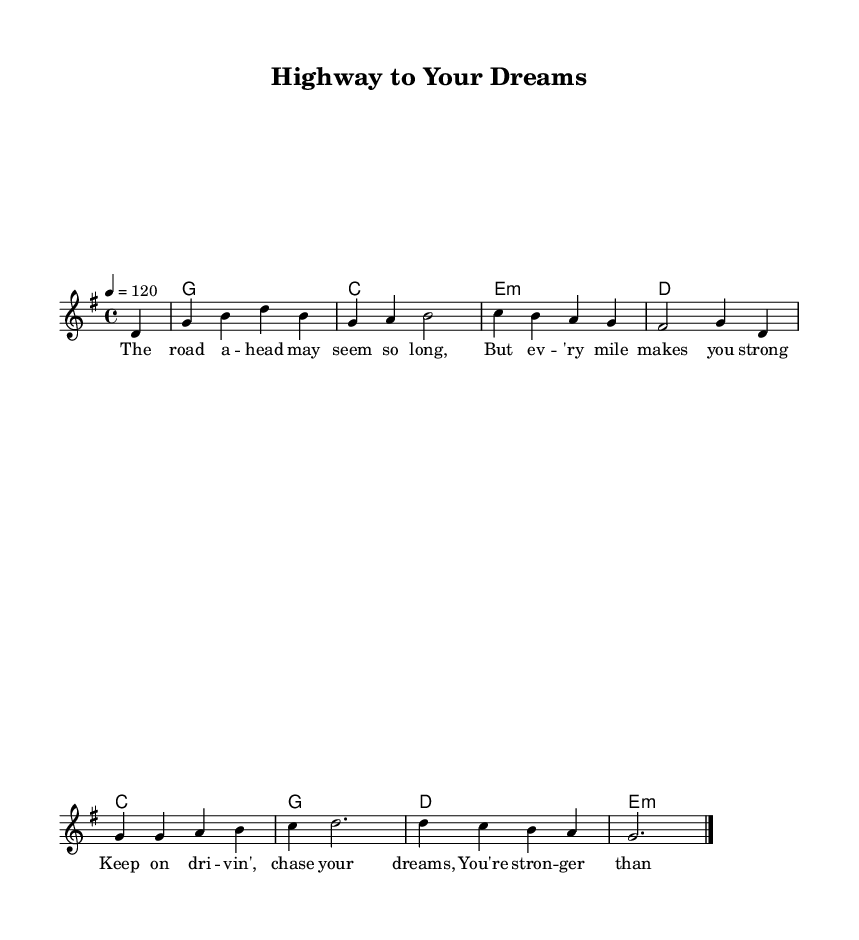What is the key signature of this music? The key signature is G major, which has one sharp (F#). This can be determined by looking at the beginning of the staff, where the key signature is indicated.
Answer: G major What is the time signature of this music? The time signature is 4/4, as shown at the beginning of the piece. It indicates there are four beats in each measure, and the quarter note gets one beat.
Answer: 4/4 What is the tempo marking for this piece? The tempo marking is 120 beats per minute, indicated by the tempo directive "4 = 120" at the start. This tells the performer how fast to play the piece.
Answer: 120 How many measures are in the melody section? There are eight measures in the melody section, which can be counted by looking at the bar lines separating the music. Each measure is divided by a vertical line, and there are eight such divisions.
Answer: Eight What is the main theme of the lyrics in this song? The main theme of the lyrics is about perseverance and self-belief as indicated by phrases like "keep on driving" and "you're stronger than you might think." This is deduced by reading through the lyrics provided beneath the melody.
Answer: Perseverance Which chords are used in the harmonies of this piece? The chords used are G, C, E minor, and D. This can be seen in the chord symbols placed above the staff, which indicate the harmonic progression throughout the piece.
Answer: G, C, E minor, D What genre does this piece belong to based on its characteristics? The genre of this piece is Country Rock. This can be inferred from the use of lyrical themes about dreams and strength, as well as the musical style characterized by a blend of country and rock elements.
Answer: Country Rock 